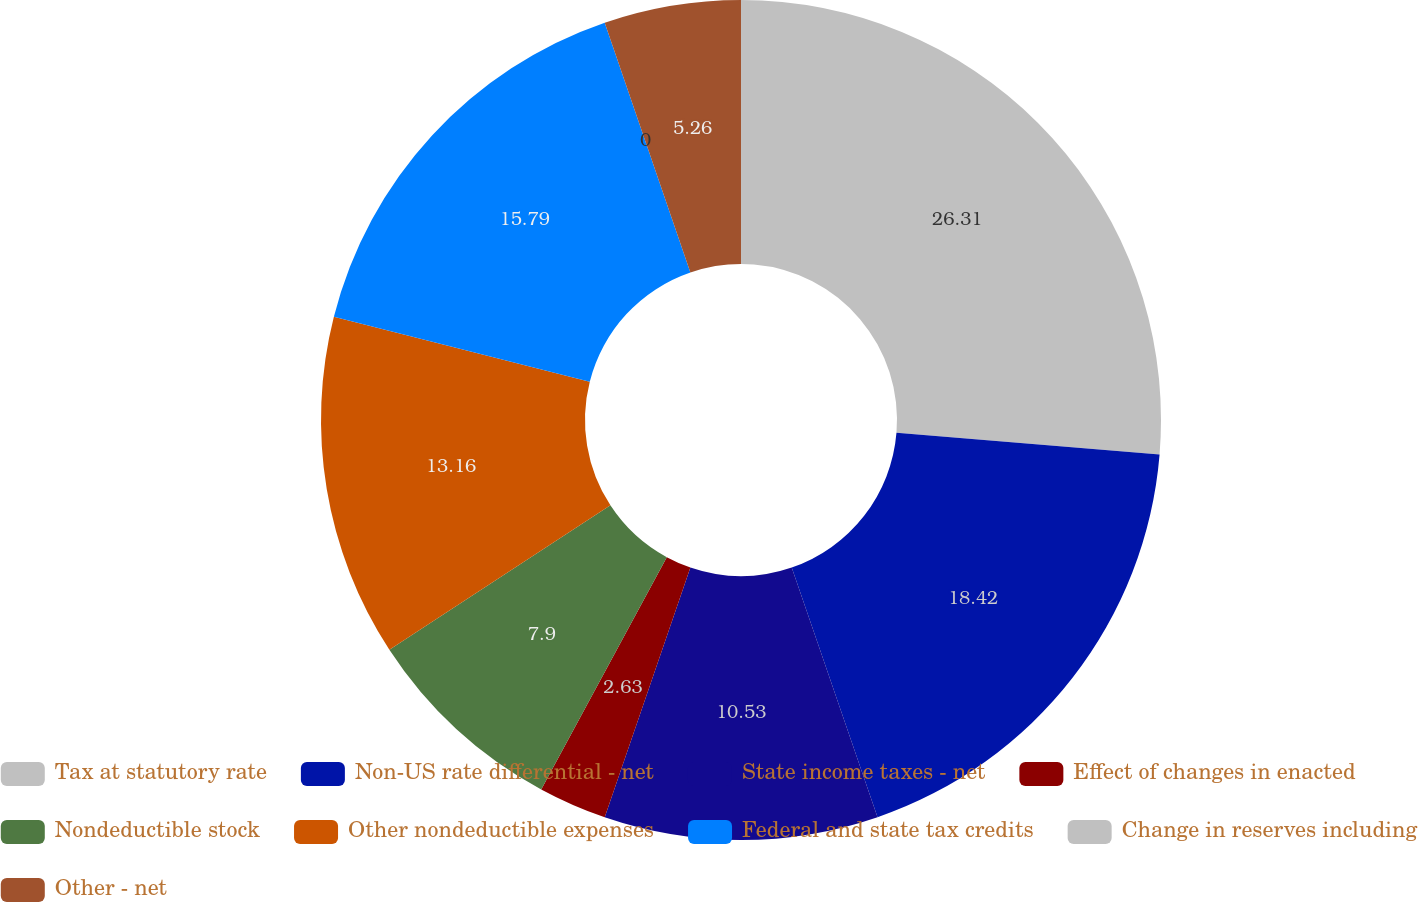<chart> <loc_0><loc_0><loc_500><loc_500><pie_chart><fcel>Tax at statutory rate<fcel>Non-US rate differential - net<fcel>State income taxes - net<fcel>Effect of changes in enacted<fcel>Nondeductible stock<fcel>Other nondeductible expenses<fcel>Federal and state tax credits<fcel>Change in reserves including<fcel>Other - net<nl><fcel>26.31%<fcel>18.42%<fcel>10.53%<fcel>2.63%<fcel>7.9%<fcel>13.16%<fcel>15.79%<fcel>0.0%<fcel>5.26%<nl></chart> 